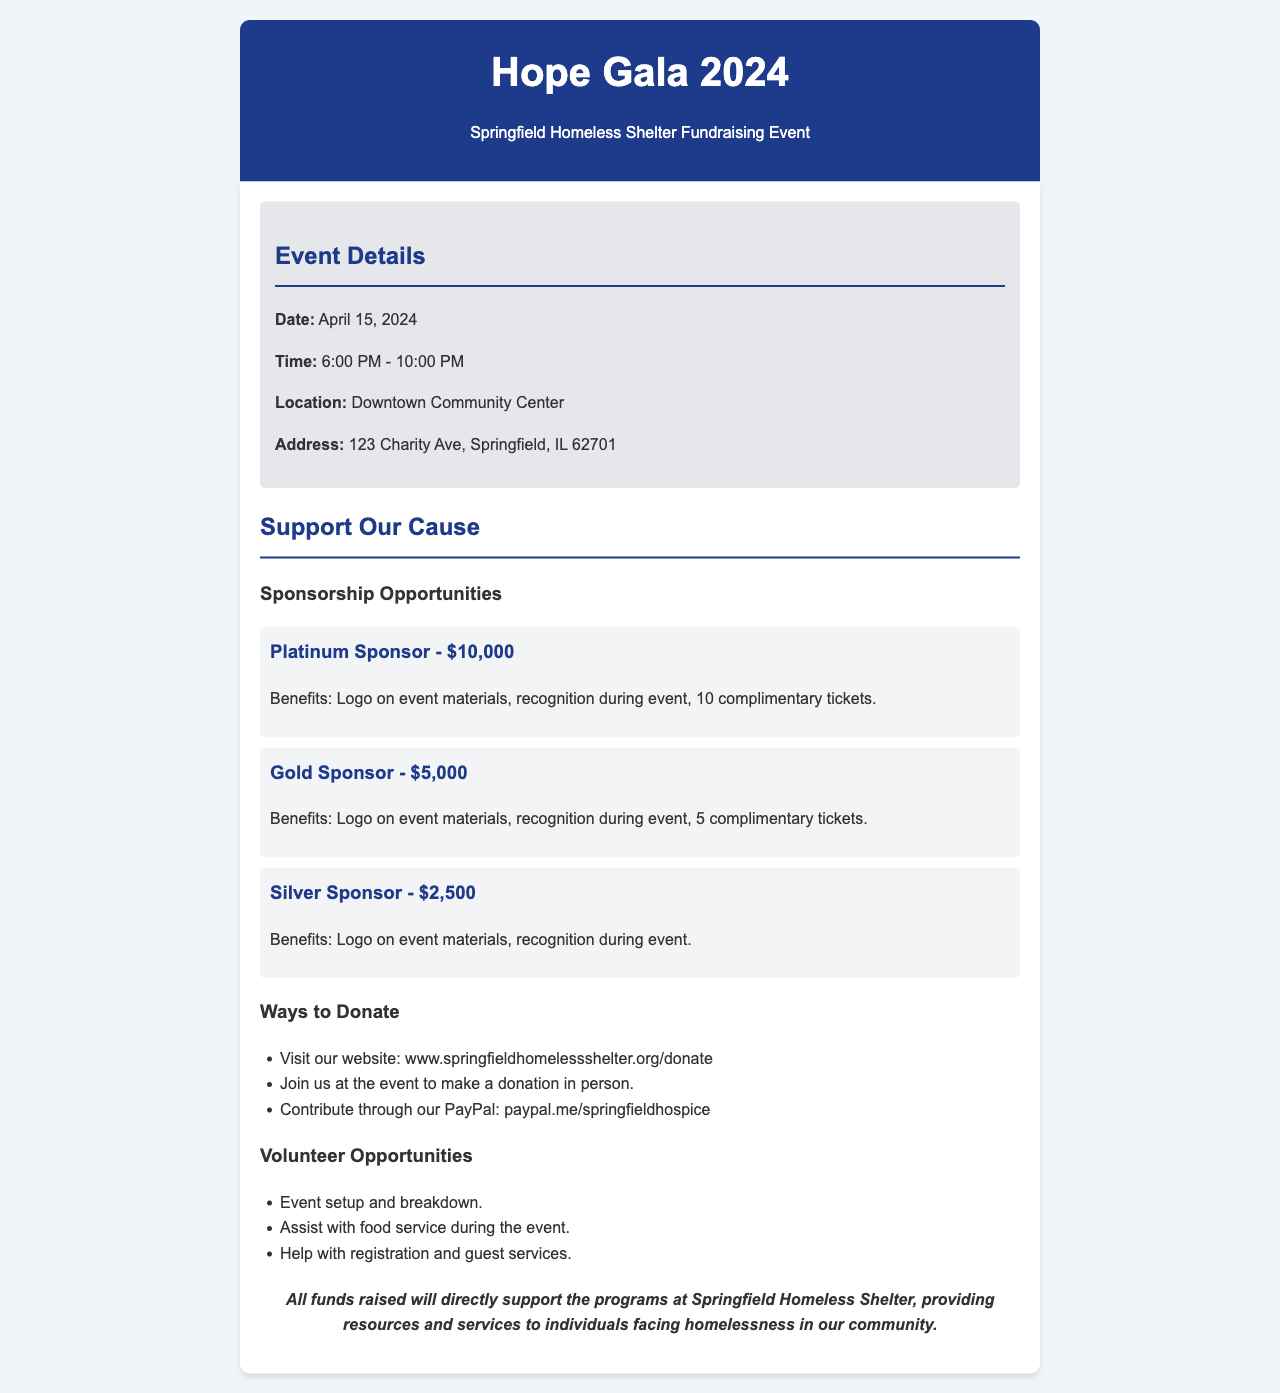What is the date of the event? The date of the event is specified in the document as April 15, 2024.
Answer: April 15, 2024 What time does the Hope Gala start? The document lists the start time for the event as 6:00 PM.
Answer: 6:00 PM Where is the event being held? The location of the event is provided in the document as Downtown Community Center.
Answer: Downtown Community Center How much is the Platinum Sponsorship? The document states that the cost for Platinum Sponsorship is $10,000.
Answer: $10,000 What is one way to donate mentioned in the document? The document lists multiple ways to donate, such as visiting the website.
Answer: Visit our website What are the volunteer opportunities available? The document highlights various volunteer opportunities, including event setup.
Answer: Event setup What benefit do Gold Sponsors receive? The document states that Gold Sponsors will receive recognition during the event.
Answer: Recognition during event How many tickets do Platinum Sponsors get? The document specifies that Platinum Sponsors receive 10 complimentary tickets.
Answer: 10 complimentary tickets What are the funds raised used for? The document mentions that all funds will support programs at Springfield Homeless Shelter.
Answer: Support the programs at Springfield Homeless Shelter 